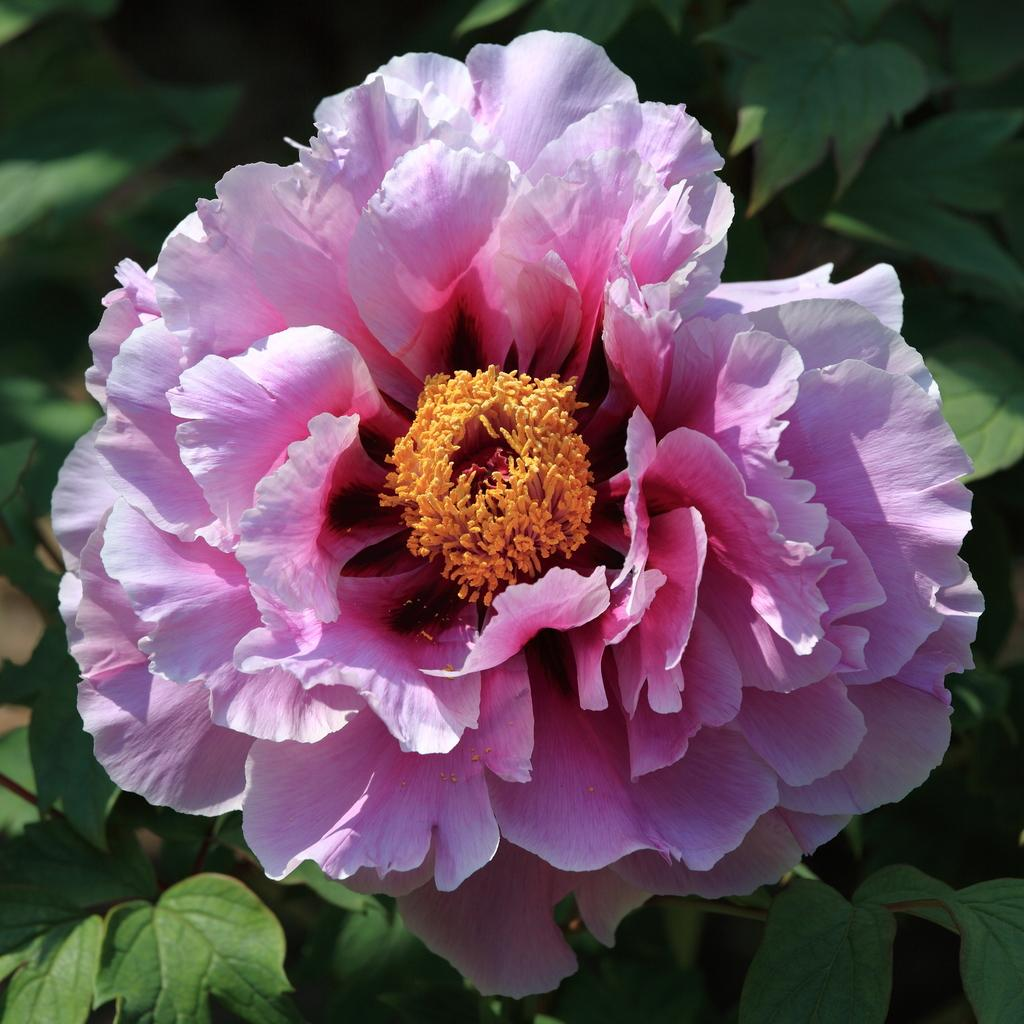What type of flower is present in the image? There is a pink color flower in the image. What can be seen in the background of the image? There are leaves in the background of the image. What type of honey can be seen dripping from the flower in the image? There is no honey present in the image; it only features a pink color flower and leaves in the background. 